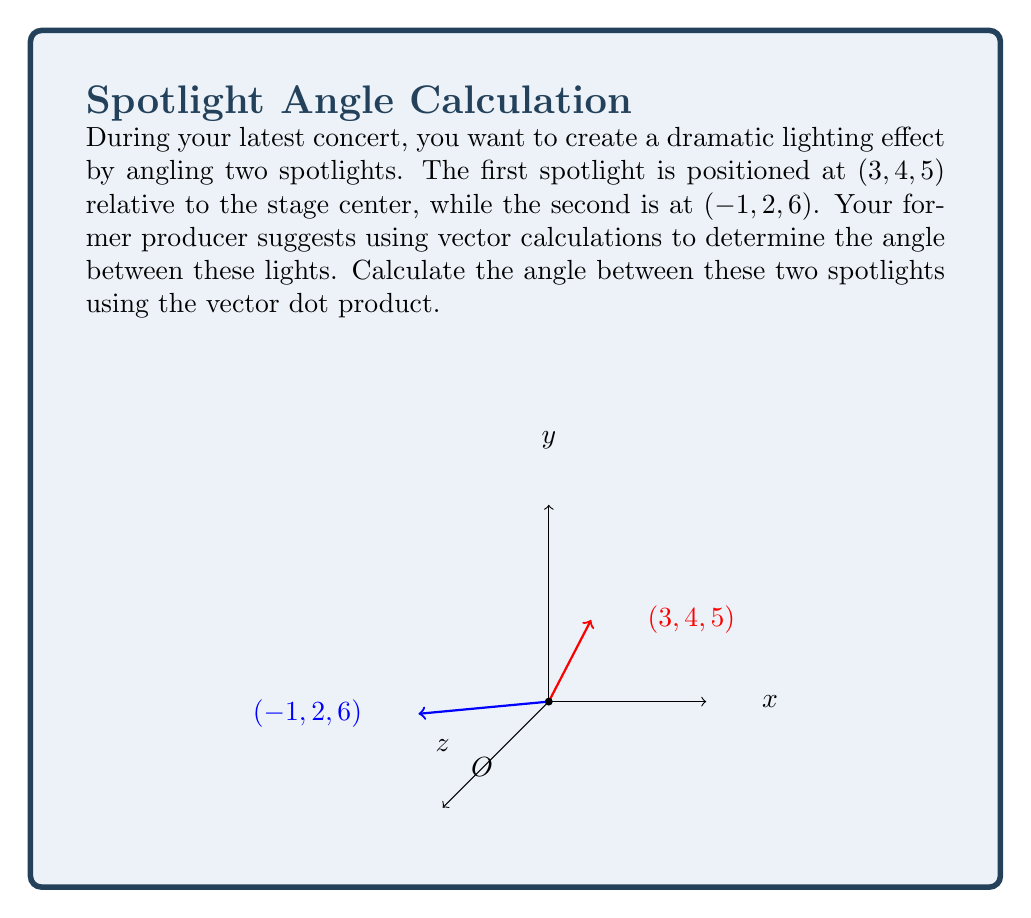Give your solution to this math problem. Let's approach this step-by-step:

1) First, we need to identify our vectors. Let's call them $\mathbf{a}$ and $\mathbf{b}$:
   $\mathbf{a} = (3, 4, 5)$
   $\mathbf{b} = (-1, 2, 6)$

2) The formula for the angle $\theta$ between two vectors using dot product is:
   $$\cos \theta = \frac{\mathbf{a} \cdot \mathbf{b}}{|\mathbf{a}||\mathbf{b}|}$$

3) Let's calculate the dot product $\mathbf{a} \cdot \mathbf{b}$:
   $\mathbf{a} \cdot \mathbf{b} = (3)(-1) + (4)(2) + (5)(6) = -3 + 8 + 30 = 35$

4) Now, we need to calculate the magnitudes of the vectors:
   $|\mathbf{a}| = \sqrt{3^2 + 4^2 + 5^2} = \sqrt{50}$
   $|\mathbf{b}| = \sqrt{(-1)^2 + 2^2 + 6^2} = \sqrt{41}$

5) Substituting into our formula:
   $$\cos \theta = \frac{35}{\sqrt{50}\sqrt{41}}$$

6) To get $\theta$, we need to take the inverse cosine (arccos) of both sides:
   $$\theta = \arccos\left(\frac{35}{\sqrt{50}\sqrt{41}}\right)$$

7) Using a calculator, we can evaluate this:
   $$\theta \approx 0.3398 \text{ radians}$$

8) Converting to degrees:
   $$\theta \approx 19.47°$$
Answer: $19.47°$ 